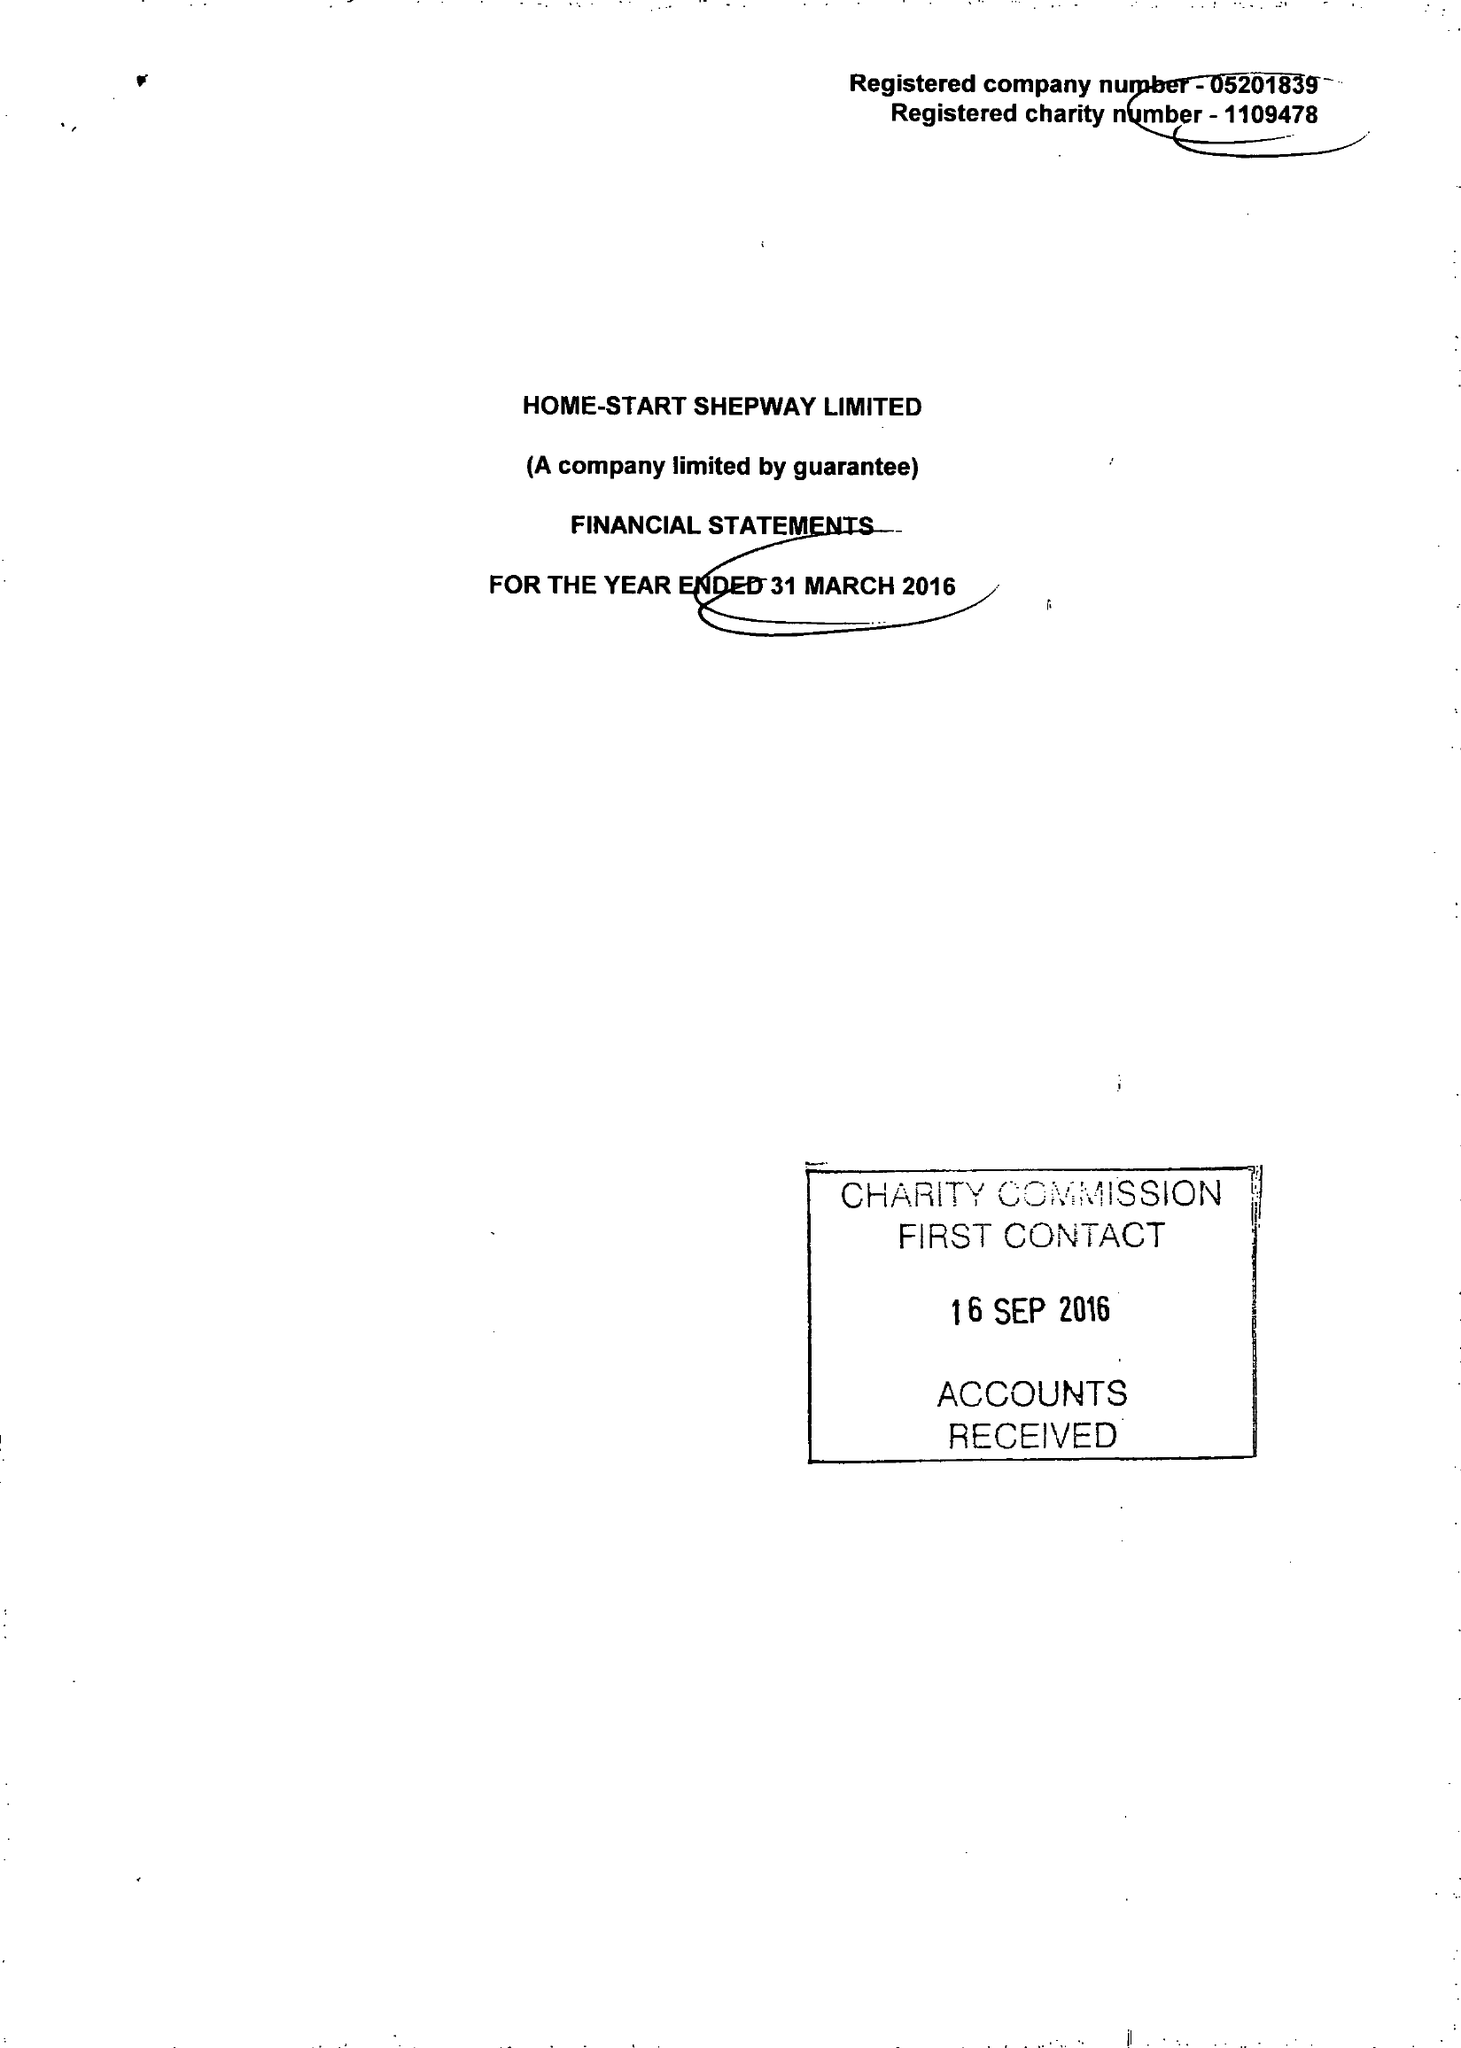What is the value for the charity_number?
Answer the question using a single word or phrase. 1109478 